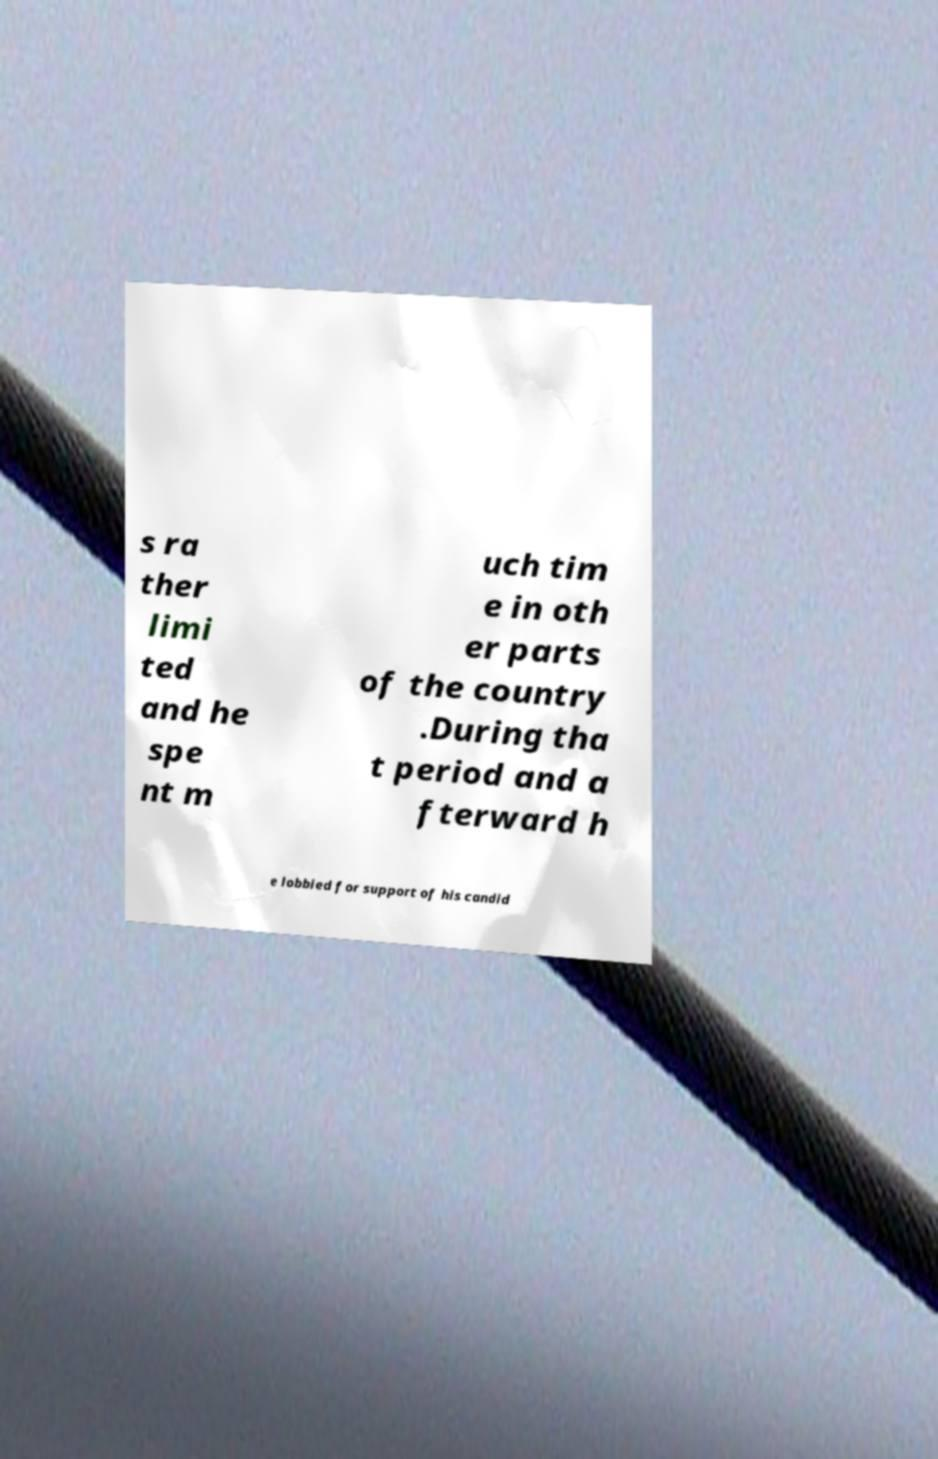Can you read and provide the text displayed in the image?This photo seems to have some interesting text. Can you extract and type it out for me? s ra ther limi ted and he spe nt m uch tim e in oth er parts of the country .During tha t period and a fterward h e lobbied for support of his candid 